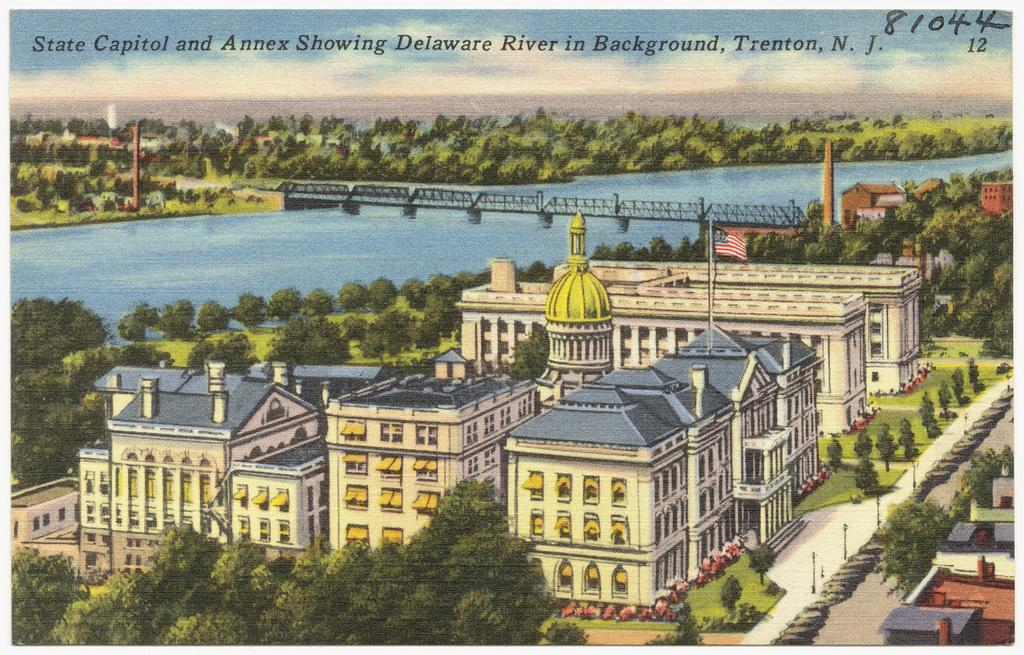<image>
Render a clear and concise summary of the photo. A postcard from Trenton N.J. is numbered 81044 in the upper corner. 